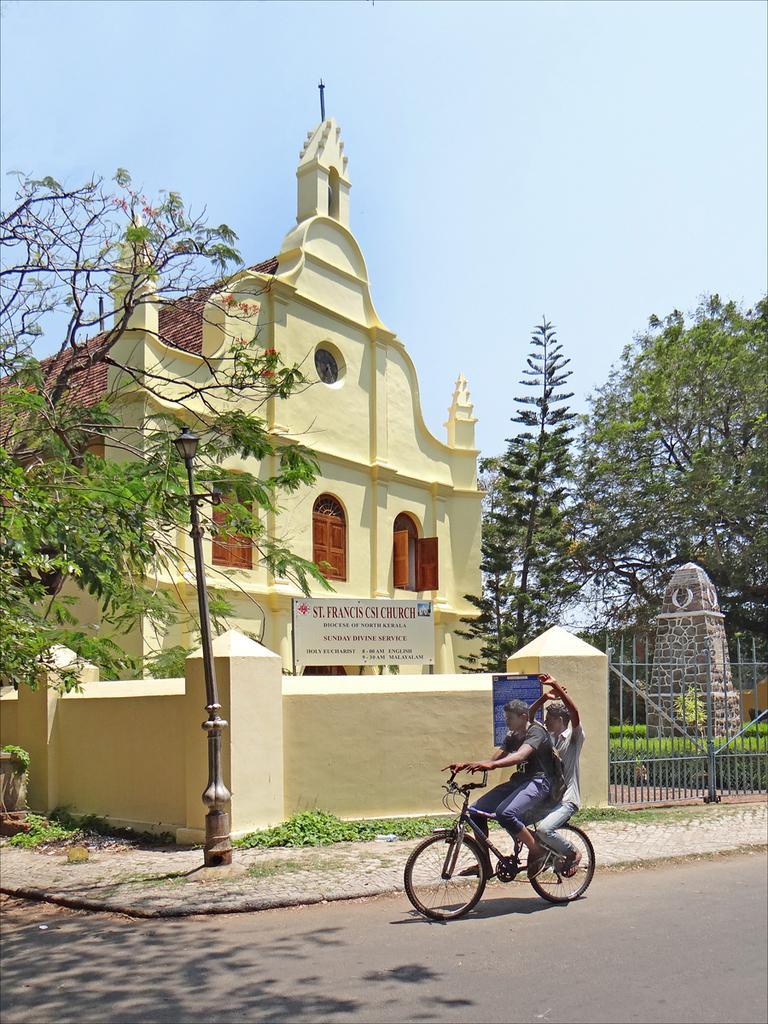Describe this image in one or two sentences. In the center of the image we can see a building. On the right side of the image we can see pillar, gate and trees. On the left side of the image we can see pole and tree. At the bottom of the image we can see persons on cycle and road. In the background there is a sky. 